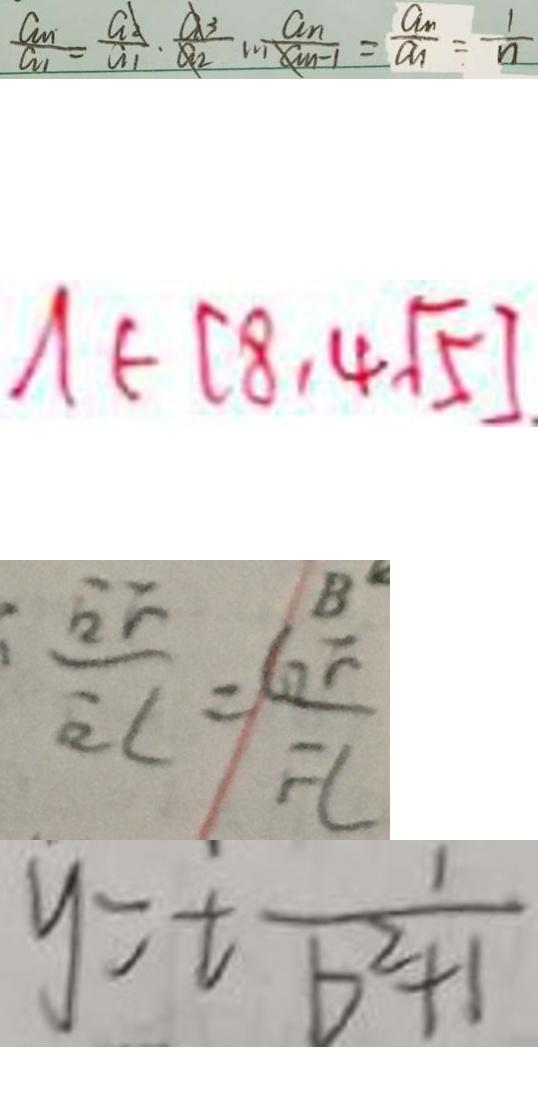Convert formula to latex. <formula><loc_0><loc_0><loc_500><loc_500>\frac { a _ { n } } { a _ { 1 } } = \frac { a _ { n } } { a _ { 1 } } \cdot \frac { a _ { 3 } } { a _ { 2 } } m \frac { a _ { n } } { a _ { n } - 1 } = \frac { a _ { n } } { a _ { n } } = \frac { 1 } { n } 
 A \in ( 8 , 4 \sqrt { 5 } ) 
 \frac { E F } { E C } = \frac { G F } { F L } 
 y = t \frac { 1 } { b ^ { 2 } + 1 }</formula> 